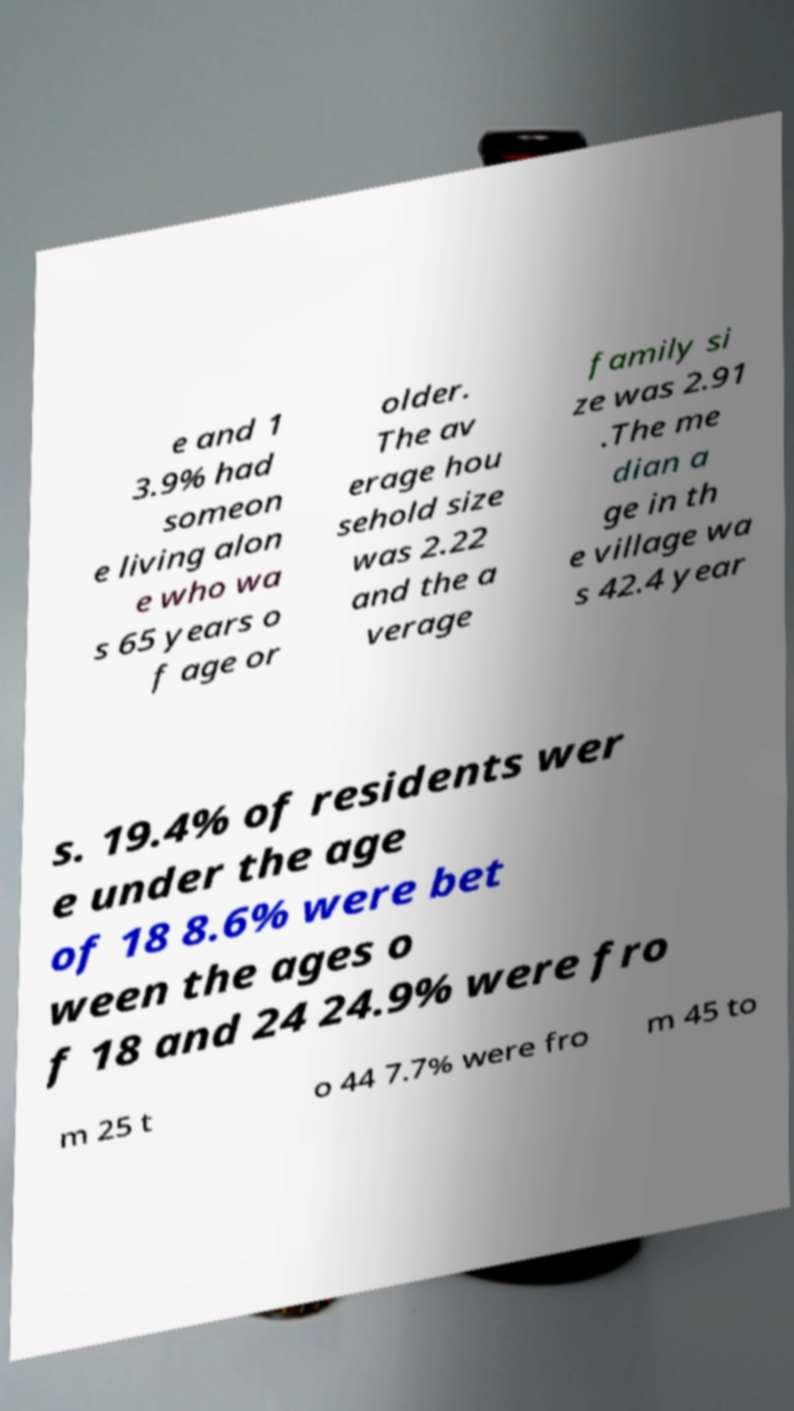Please read and relay the text visible in this image. What does it say? e and 1 3.9% had someon e living alon e who wa s 65 years o f age or older. The av erage hou sehold size was 2.22 and the a verage family si ze was 2.91 .The me dian a ge in th e village wa s 42.4 year s. 19.4% of residents wer e under the age of 18 8.6% were bet ween the ages o f 18 and 24 24.9% were fro m 25 t o 44 7.7% were fro m 45 to 